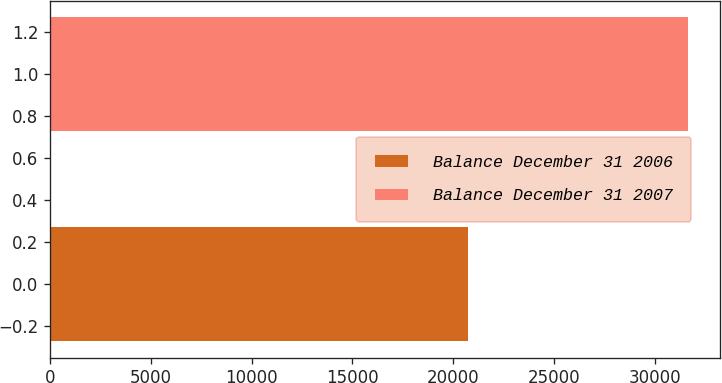<chart> <loc_0><loc_0><loc_500><loc_500><bar_chart><fcel>Balance December 31 2006<fcel>Balance December 31 2007<nl><fcel>20712<fcel>31627<nl></chart> 